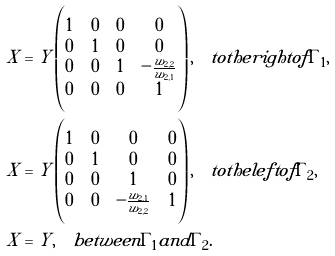Convert formula to latex. <formula><loc_0><loc_0><loc_500><loc_500>X & = Y \begin{pmatrix} 1 & 0 & 0 & 0 \\ 0 & 1 & 0 & 0 \\ 0 & 0 & 1 & - \frac { w _ { 2 , 2 } } { w _ { 2 , 1 } } \\ 0 & 0 & 0 & 1 \end{pmatrix} , \quad t o t h e r i g h t o f \Gamma _ { 1 } , \\ X & = Y \begin{pmatrix} 1 & 0 & 0 & 0 \\ 0 & 1 & 0 & 0 \\ 0 & 0 & 1 & 0 \\ 0 & 0 & - \frac { w _ { 2 , 1 } } { w _ { 2 , 2 } } & 1 \end{pmatrix} , \quad t o t h e l e f t o f \Gamma _ { 2 } , \\ X & = Y , \quad b e t w e e n \Gamma _ { 1 } a n d \Gamma _ { 2 } .</formula> 